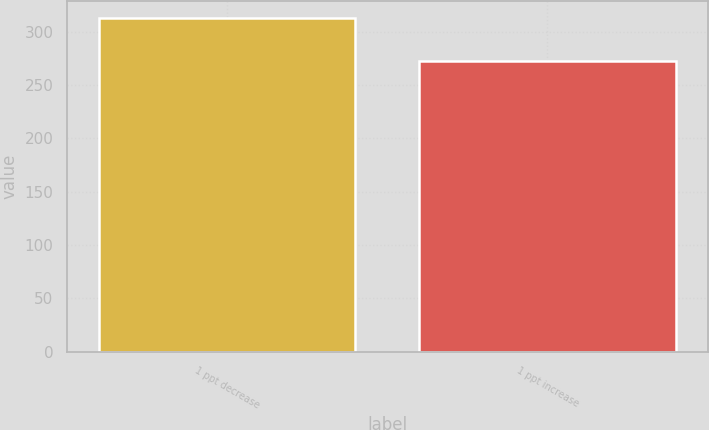Convert chart. <chart><loc_0><loc_0><loc_500><loc_500><bar_chart><fcel>1 ppt decrease<fcel>1 ppt increase<nl><fcel>313<fcel>273<nl></chart> 